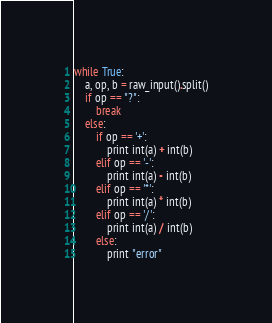Convert code to text. <code><loc_0><loc_0><loc_500><loc_500><_Python_>while True:
    a, op, b = raw_input().split()
    if op == "?":
        break
    else:
        if op == '+':
            print int(a) + int(b)
        elif op == '-':
            print int(a) - int(b)
        elif op == '*':
            print int(a) * int(b)
        elif op == '/':
            print int(a) / int(b)
        else:
            print "error"</code> 